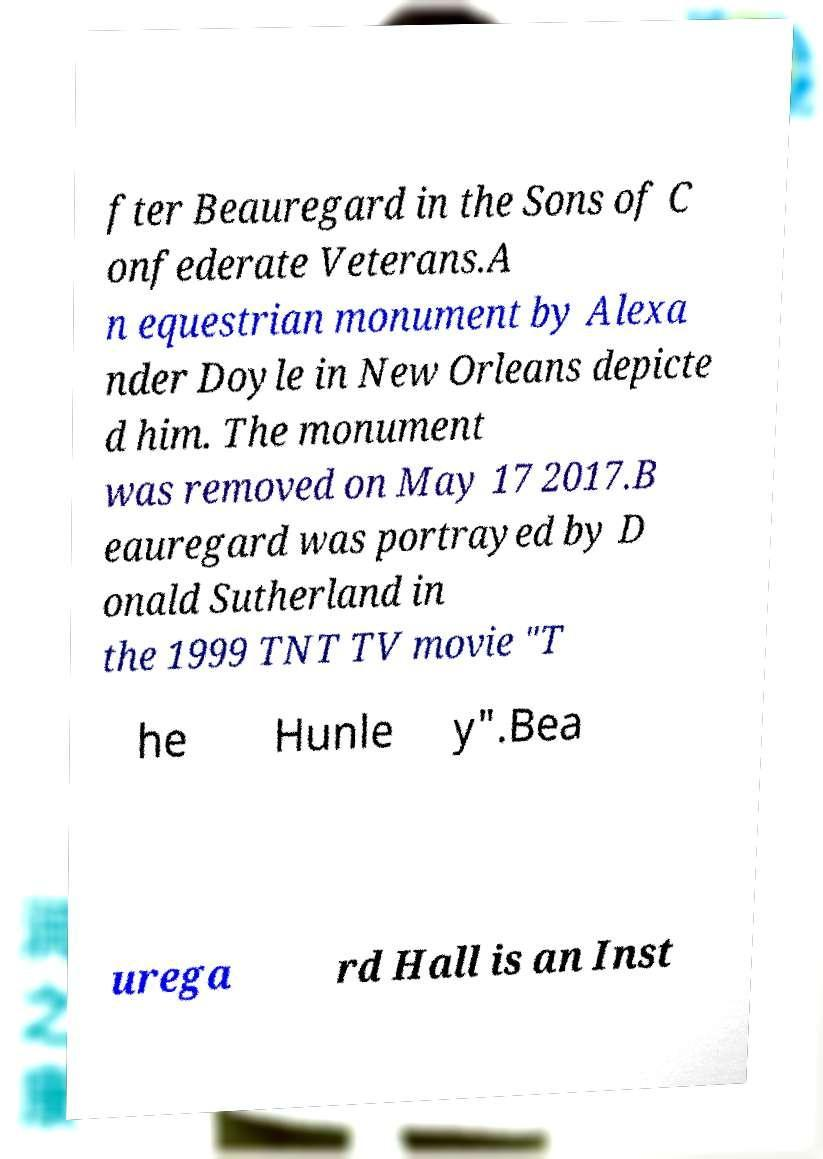Please read and relay the text visible in this image. What does it say? fter Beauregard in the Sons of C onfederate Veterans.A n equestrian monument by Alexa nder Doyle in New Orleans depicte d him. The monument was removed on May 17 2017.B eauregard was portrayed by D onald Sutherland in the 1999 TNT TV movie "T he Hunle y".Bea urega rd Hall is an Inst 